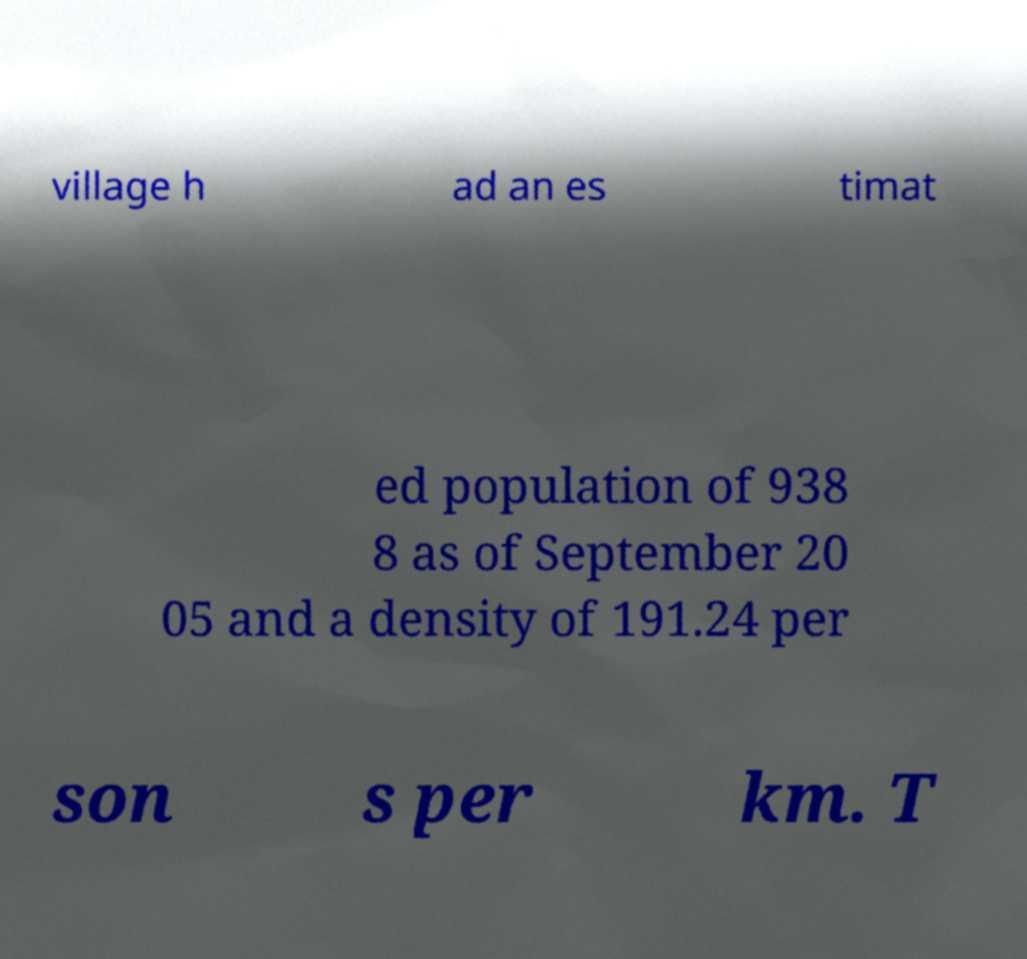Please read and relay the text visible in this image. What does it say? village h ad an es timat ed population of 938 8 as of September 20 05 and a density of 191.24 per son s per km. T 